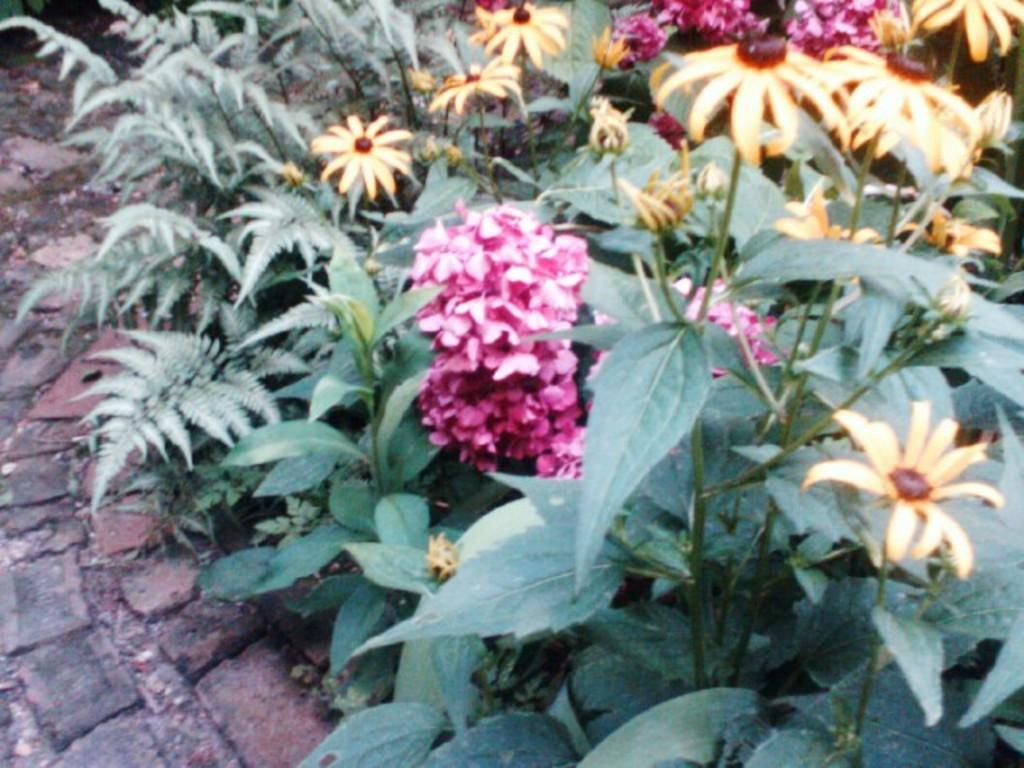What type of living organisms can be seen in the image? Plants and flowers are visible in the image. How are some of the plants and flowers depicted in the image? Some of the plants and flowers are truncated. Can you describe the ground in the image? There are bricks on the ground in the image. What type of map can be seen in the image? There is no map present in the image. Can you tell me what the parent of the flowers is thinking in the image? There is no parent or thought process depicted in the image; it features plants, flowers, and bricks. 